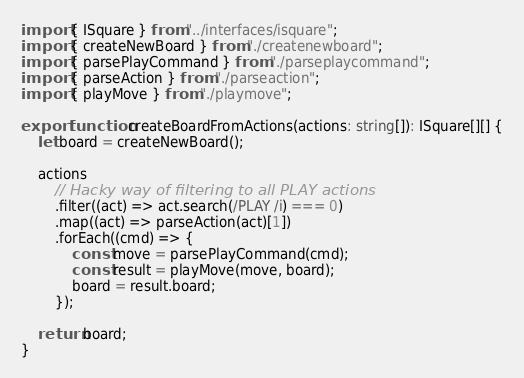Convert code to text. <code><loc_0><loc_0><loc_500><loc_500><_TypeScript_>import { ISquare } from "../interfaces/isquare";
import { createNewBoard } from "./createnewboard";
import { parsePlayCommand } from "./parseplaycommand";
import { parseAction } from "./parseaction";
import { playMove } from "./playmove";

export function createBoardFromActions(actions: string[]): ISquare[][] {
    let board = createNewBoard();

    actions
        // Hacky way of filtering to all PLAY actions
        .filter((act) => act.search(/PLAY /i) === 0)
        .map((act) => parseAction(act)[1])
        .forEach((cmd) => {
            const move = parsePlayCommand(cmd);
            const result = playMove(move, board);
            board = result.board;
        });

    return board;
}
</code> 